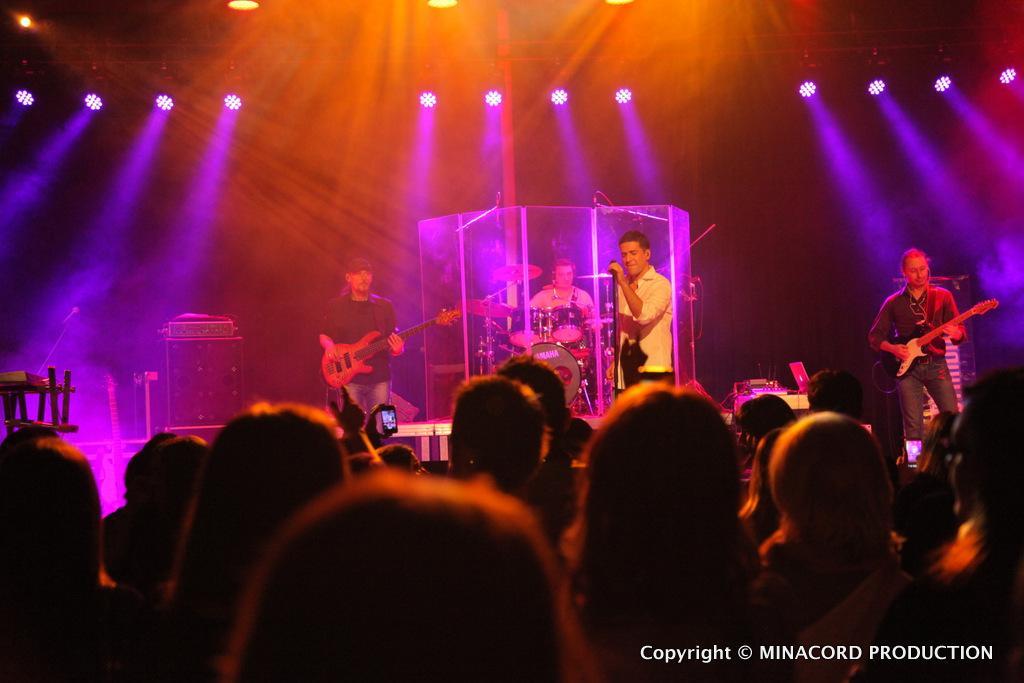In one or two sentences, can you explain what this image depicts? In this picture I can see audience and few people standing on the dais and playing musical instruments and a man holding a microphone and I can see few lights to the ceiling and text at the bottom right corner of the picture. 